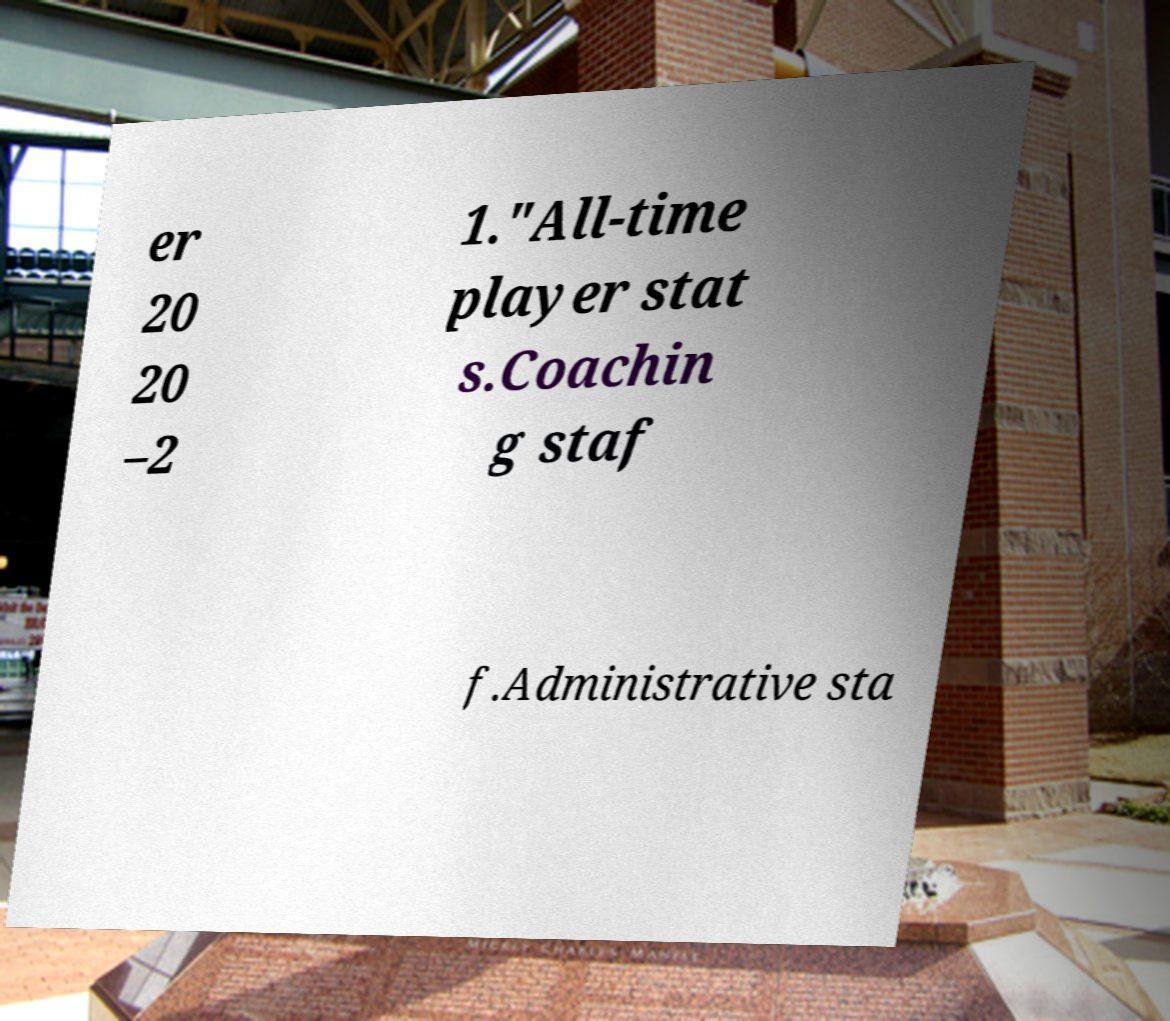What messages or text are displayed in this image? I need them in a readable, typed format. er 20 20 –2 1."All-time player stat s.Coachin g staf f.Administrative sta 